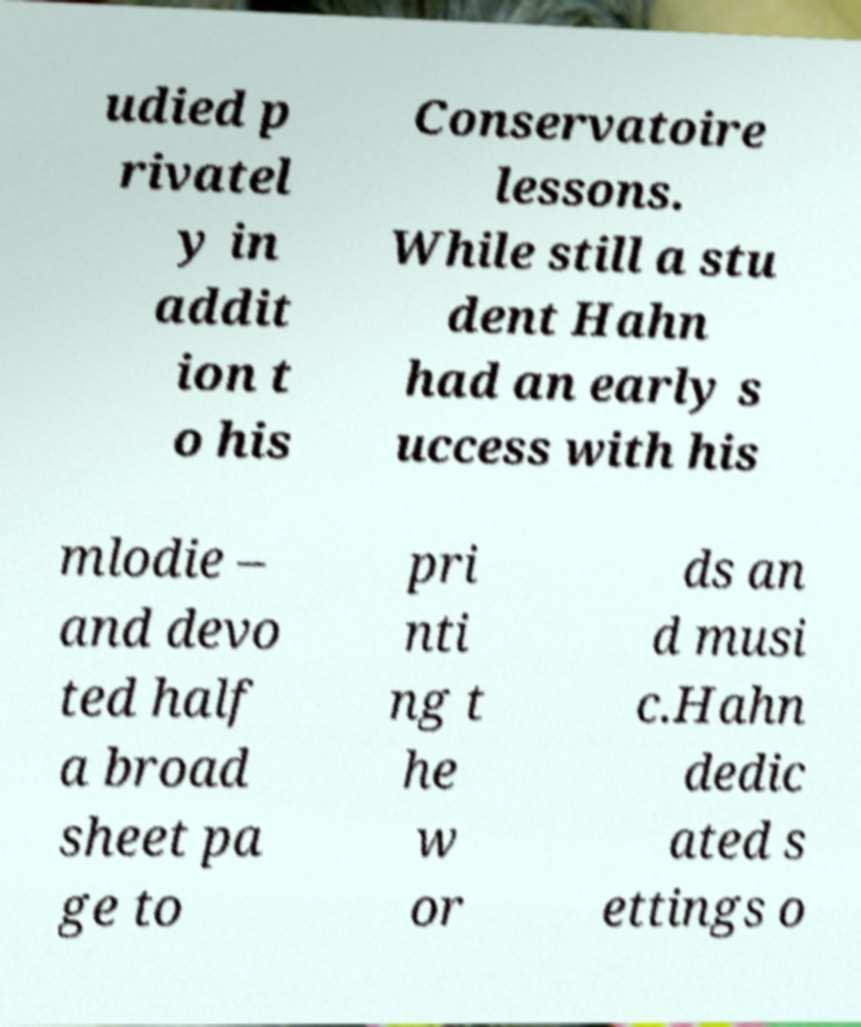Could you assist in decoding the text presented in this image and type it out clearly? udied p rivatel y in addit ion t o his Conservatoire lessons. While still a stu dent Hahn had an early s uccess with his mlodie – and devo ted half a broad sheet pa ge to pri nti ng t he w or ds an d musi c.Hahn dedic ated s ettings o 